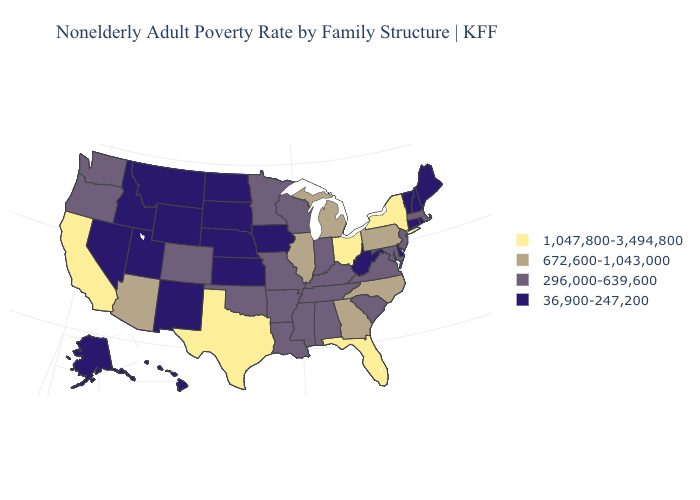What is the value of Vermont?
Concise answer only. 36,900-247,200. Name the states that have a value in the range 672,600-1,043,000?
Concise answer only. Arizona, Georgia, Illinois, Michigan, North Carolina, Pennsylvania. Does Minnesota have the lowest value in the USA?
Give a very brief answer. No. What is the lowest value in the USA?
Write a very short answer. 36,900-247,200. Which states have the lowest value in the West?
Write a very short answer. Alaska, Hawaii, Idaho, Montana, Nevada, New Mexico, Utah, Wyoming. Name the states that have a value in the range 36,900-247,200?
Be succinct. Alaska, Connecticut, Delaware, Hawaii, Idaho, Iowa, Kansas, Maine, Montana, Nebraska, Nevada, New Hampshire, New Mexico, North Dakota, Rhode Island, South Dakota, Utah, Vermont, West Virginia, Wyoming. Is the legend a continuous bar?
Concise answer only. No. What is the value of Illinois?
Short answer required. 672,600-1,043,000. Name the states that have a value in the range 296,000-639,600?
Keep it brief. Alabama, Arkansas, Colorado, Indiana, Kentucky, Louisiana, Maryland, Massachusetts, Minnesota, Mississippi, Missouri, New Jersey, Oklahoma, Oregon, South Carolina, Tennessee, Virginia, Washington, Wisconsin. Does West Virginia have the lowest value in the South?
Quick response, please. Yes. What is the value of Missouri?
Answer briefly. 296,000-639,600. Which states have the lowest value in the USA?
Concise answer only. Alaska, Connecticut, Delaware, Hawaii, Idaho, Iowa, Kansas, Maine, Montana, Nebraska, Nevada, New Hampshire, New Mexico, North Dakota, Rhode Island, South Dakota, Utah, Vermont, West Virginia, Wyoming. Name the states that have a value in the range 36,900-247,200?
Give a very brief answer. Alaska, Connecticut, Delaware, Hawaii, Idaho, Iowa, Kansas, Maine, Montana, Nebraska, Nevada, New Hampshire, New Mexico, North Dakota, Rhode Island, South Dakota, Utah, Vermont, West Virginia, Wyoming. Does Wisconsin have the highest value in the USA?
Concise answer only. No. What is the value of Nebraska?
Concise answer only. 36,900-247,200. 